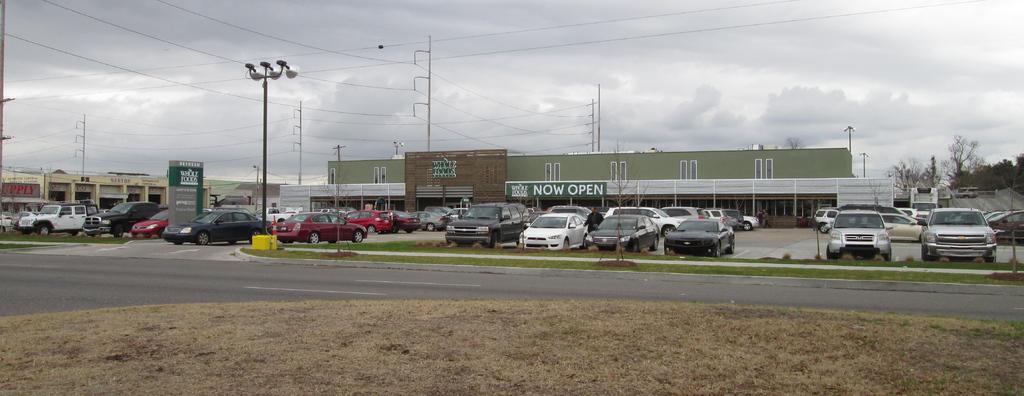What does the banner on the store say?
Offer a terse response. Now open. What retail establishment is this?
Your answer should be very brief. Whole foods. 